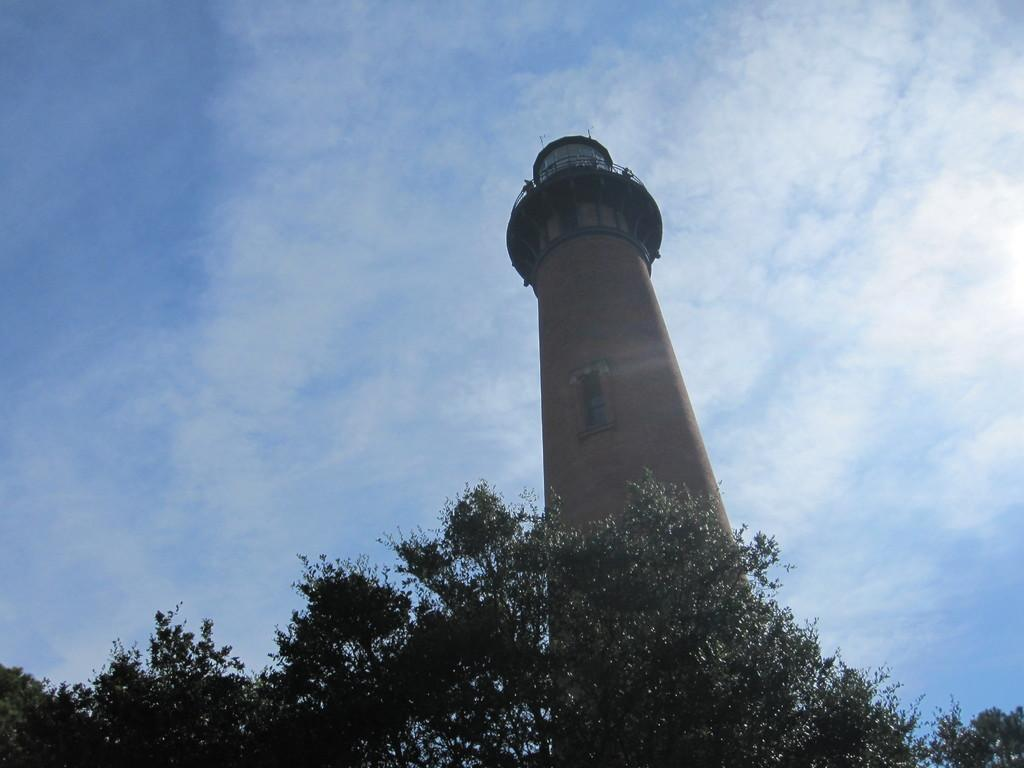What is the main structure in the image? There is a lighthouse tower in the image. How big is the lighthouse tower? The lighthouse tower is huge. Where is the lighthouse tower located in the image? The lighthouse tower is in the middle of the image. What type of vegetation is visible in the image? There are trees in the front of the image. What type of skirt is the lighthouse tower wearing in the image? The lighthouse tower is not wearing a skirt, as it is a structure and not a person. 